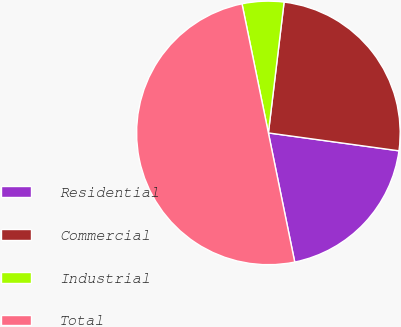Convert chart. <chart><loc_0><loc_0><loc_500><loc_500><pie_chart><fcel>Residential<fcel>Commercial<fcel>Industrial<fcel>Total<nl><fcel>19.63%<fcel>25.27%<fcel>5.11%<fcel>50.0%<nl></chart> 